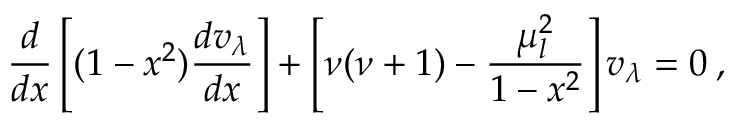<formula> <loc_0><loc_0><loc_500><loc_500>\frac { d } { d x } \left [ ( 1 - x ^ { 2 } ) \frac { d v _ { \lambda } } { d x } \right ] + \left [ \nu ( \nu + 1 ) - \frac { \mu _ { l } ^ { 2 } } { 1 - x ^ { 2 } } \right ] v _ { \lambda } = 0 \, ,</formula> 